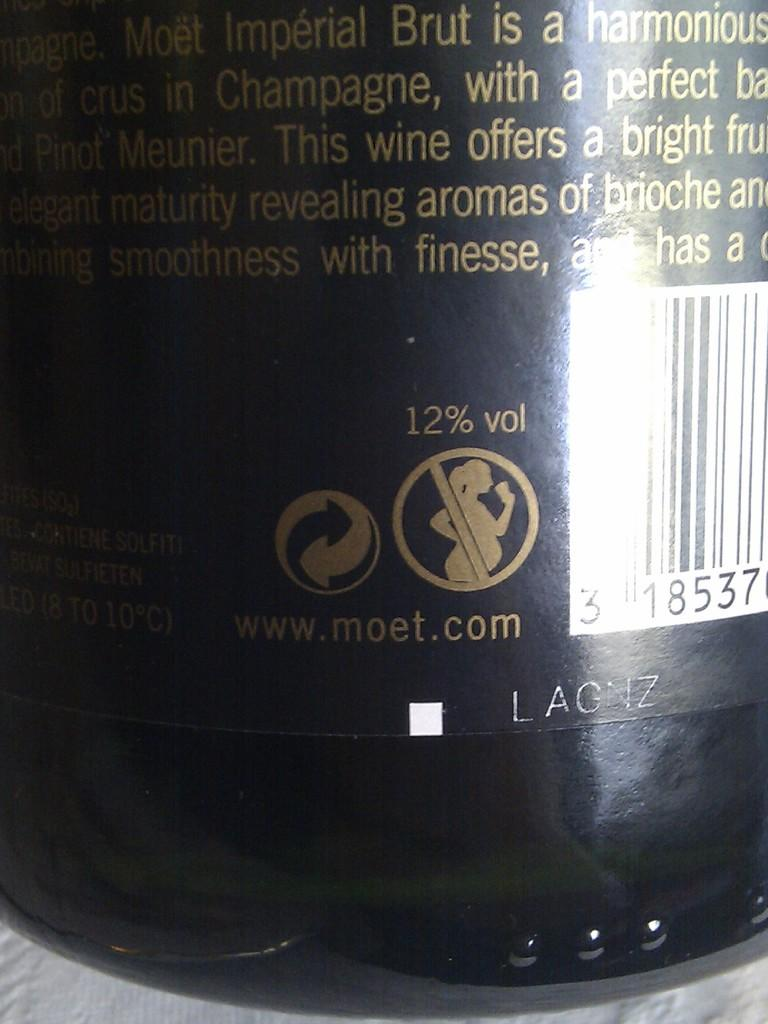Provide a one-sentence caption for the provided image. Bottle with a label that says LAGNZ on the bottom. 